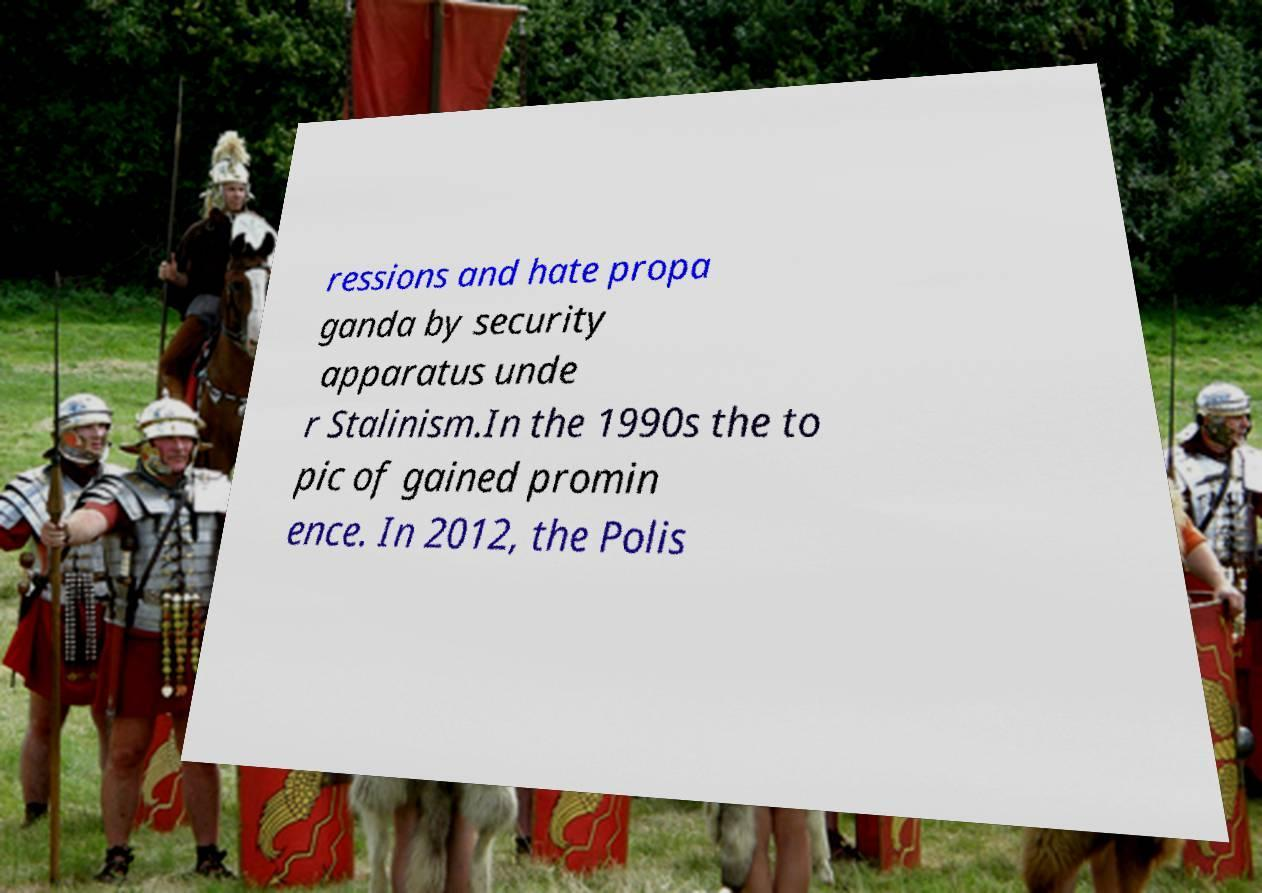Can you read and provide the text displayed in the image?This photo seems to have some interesting text. Can you extract and type it out for me? ressions and hate propa ganda by security apparatus unde r Stalinism.In the 1990s the to pic of gained promin ence. In 2012, the Polis 